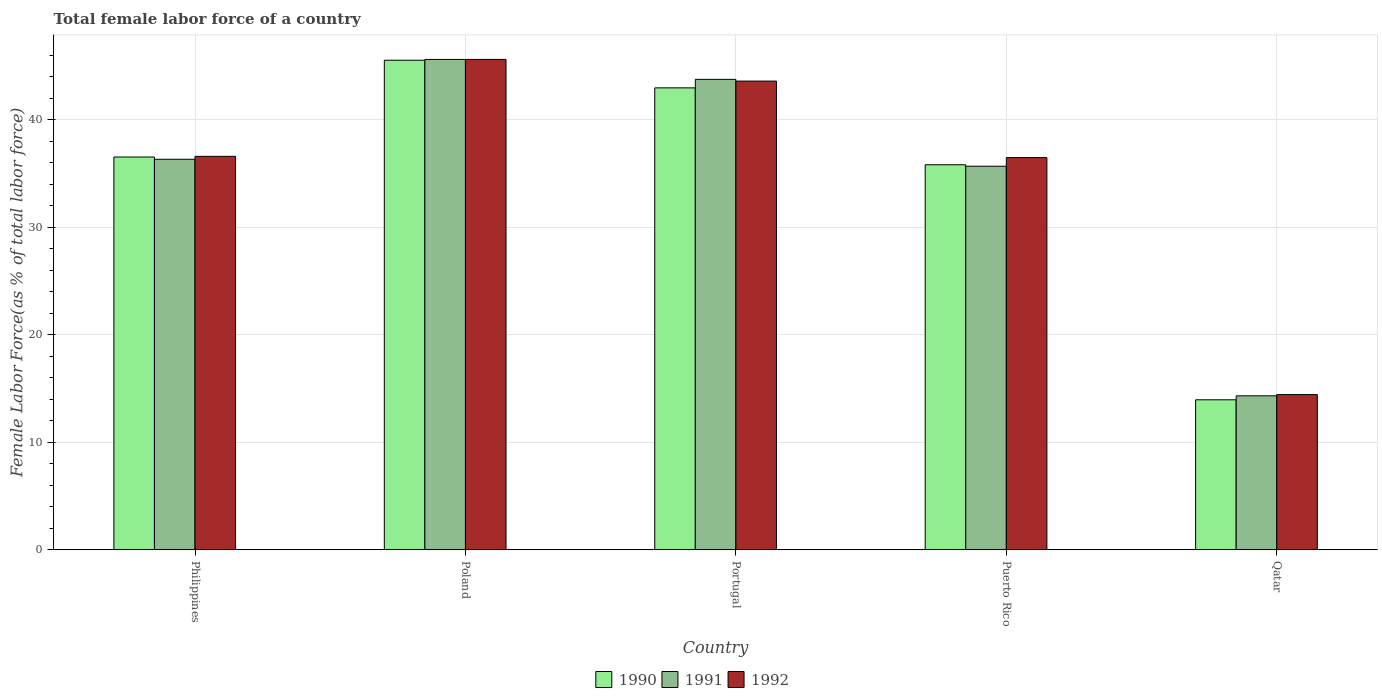How many groups of bars are there?
Give a very brief answer. 5. Are the number of bars per tick equal to the number of legend labels?
Offer a very short reply. Yes. How many bars are there on the 5th tick from the left?
Your answer should be compact. 3. How many bars are there on the 4th tick from the right?
Your answer should be very brief. 3. What is the percentage of female labor force in 1992 in Portugal?
Offer a very short reply. 43.6. Across all countries, what is the maximum percentage of female labor force in 1992?
Make the answer very short. 45.62. Across all countries, what is the minimum percentage of female labor force in 1992?
Provide a succinct answer. 14.44. In which country was the percentage of female labor force in 1992 maximum?
Your answer should be compact. Poland. In which country was the percentage of female labor force in 1990 minimum?
Make the answer very short. Qatar. What is the total percentage of female labor force in 1990 in the graph?
Offer a terse response. 174.84. What is the difference between the percentage of female labor force in 1991 in Philippines and that in Portugal?
Provide a succinct answer. -7.44. What is the difference between the percentage of female labor force in 1992 in Puerto Rico and the percentage of female labor force in 1990 in Portugal?
Your answer should be compact. -6.48. What is the average percentage of female labor force in 1992 per country?
Your answer should be very brief. 35.35. What is the difference between the percentage of female labor force of/in 1992 and percentage of female labor force of/in 1990 in Philippines?
Make the answer very short. 0.06. What is the ratio of the percentage of female labor force in 1992 in Philippines to that in Qatar?
Provide a short and direct response. 2.53. Is the percentage of female labor force in 1990 in Puerto Rico less than that in Qatar?
Your answer should be compact. No. What is the difference between the highest and the second highest percentage of female labor force in 1992?
Your answer should be very brief. 7. What is the difference between the highest and the lowest percentage of female labor force in 1992?
Ensure brevity in your answer.  31.18. What does the 1st bar from the left in Portugal represents?
Your response must be concise. 1990. What does the 3rd bar from the right in Philippines represents?
Offer a terse response. 1990. Is it the case that in every country, the sum of the percentage of female labor force in 1991 and percentage of female labor force in 1992 is greater than the percentage of female labor force in 1990?
Your response must be concise. Yes. Are all the bars in the graph horizontal?
Ensure brevity in your answer.  No. How many countries are there in the graph?
Your response must be concise. 5. How are the legend labels stacked?
Your answer should be compact. Horizontal. What is the title of the graph?
Offer a terse response. Total female labor force of a country. What is the label or title of the Y-axis?
Offer a very short reply. Female Labor Force(as % of total labor force). What is the Female Labor Force(as % of total labor force) of 1990 in Philippines?
Your answer should be compact. 36.54. What is the Female Labor Force(as % of total labor force) in 1991 in Philippines?
Ensure brevity in your answer.  36.33. What is the Female Labor Force(as % of total labor force) in 1992 in Philippines?
Keep it short and to the point. 36.6. What is the Female Labor Force(as % of total labor force) of 1990 in Poland?
Provide a succinct answer. 45.55. What is the Female Labor Force(as % of total labor force) in 1991 in Poland?
Keep it short and to the point. 45.62. What is the Female Labor Force(as % of total labor force) in 1992 in Poland?
Make the answer very short. 45.62. What is the Female Labor Force(as % of total labor force) in 1990 in Portugal?
Your answer should be very brief. 42.97. What is the Female Labor Force(as % of total labor force) of 1991 in Portugal?
Your answer should be compact. 43.77. What is the Female Labor Force(as % of total labor force) of 1992 in Portugal?
Give a very brief answer. 43.6. What is the Female Labor Force(as % of total labor force) in 1990 in Puerto Rico?
Make the answer very short. 35.82. What is the Female Labor Force(as % of total labor force) of 1991 in Puerto Rico?
Keep it short and to the point. 35.69. What is the Female Labor Force(as % of total labor force) of 1992 in Puerto Rico?
Your answer should be compact. 36.49. What is the Female Labor Force(as % of total labor force) of 1990 in Qatar?
Ensure brevity in your answer.  13.96. What is the Female Labor Force(as % of total labor force) of 1991 in Qatar?
Make the answer very short. 14.33. What is the Female Labor Force(as % of total labor force) of 1992 in Qatar?
Give a very brief answer. 14.44. Across all countries, what is the maximum Female Labor Force(as % of total labor force) in 1990?
Your response must be concise. 45.55. Across all countries, what is the maximum Female Labor Force(as % of total labor force) of 1991?
Your answer should be compact. 45.62. Across all countries, what is the maximum Female Labor Force(as % of total labor force) in 1992?
Ensure brevity in your answer.  45.62. Across all countries, what is the minimum Female Labor Force(as % of total labor force) of 1990?
Your answer should be compact. 13.96. Across all countries, what is the minimum Female Labor Force(as % of total labor force) in 1991?
Offer a terse response. 14.33. Across all countries, what is the minimum Female Labor Force(as % of total labor force) in 1992?
Your answer should be compact. 14.44. What is the total Female Labor Force(as % of total labor force) in 1990 in the graph?
Provide a succinct answer. 174.84. What is the total Female Labor Force(as % of total labor force) in 1991 in the graph?
Provide a succinct answer. 175.73. What is the total Female Labor Force(as % of total labor force) in 1992 in the graph?
Provide a succinct answer. 176.76. What is the difference between the Female Labor Force(as % of total labor force) in 1990 in Philippines and that in Poland?
Your response must be concise. -9. What is the difference between the Female Labor Force(as % of total labor force) of 1991 in Philippines and that in Poland?
Your answer should be compact. -9.29. What is the difference between the Female Labor Force(as % of total labor force) of 1992 in Philippines and that in Poland?
Your answer should be compact. -9.02. What is the difference between the Female Labor Force(as % of total labor force) in 1990 in Philippines and that in Portugal?
Ensure brevity in your answer.  -6.43. What is the difference between the Female Labor Force(as % of total labor force) in 1991 in Philippines and that in Portugal?
Make the answer very short. -7.44. What is the difference between the Female Labor Force(as % of total labor force) in 1992 in Philippines and that in Portugal?
Offer a terse response. -7. What is the difference between the Female Labor Force(as % of total labor force) in 1990 in Philippines and that in Puerto Rico?
Give a very brief answer. 0.72. What is the difference between the Female Labor Force(as % of total labor force) of 1991 in Philippines and that in Puerto Rico?
Give a very brief answer. 0.64. What is the difference between the Female Labor Force(as % of total labor force) in 1992 in Philippines and that in Puerto Rico?
Make the answer very short. 0.11. What is the difference between the Female Labor Force(as % of total labor force) of 1990 in Philippines and that in Qatar?
Your answer should be compact. 22.58. What is the difference between the Female Labor Force(as % of total labor force) of 1991 in Philippines and that in Qatar?
Ensure brevity in your answer.  22. What is the difference between the Female Labor Force(as % of total labor force) of 1992 in Philippines and that in Qatar?
Keep it short and to the point. 22.16. What is the difference between the Female Labor Force(as % of total labor force) in 1990 in Poland and that in Portugal?
Offer a terse response. 2.57. What is the difference between the Female Labor Force(as % of total labor force) of 1991 in Poland and that in Portugal?
Your response must be concise. 1.85. What is the difference between the Female Labor Force(as % of total labor force) in 1992 in Poland and that in Portugal?
Your response must be concise. 2.02. What is the difference between the Female Labor Force(as % of total labor force) of 1990 in Poland and that in Puerto Rico?
Provide a short and direct response. 9.72. What is the difference between the Female Labor Force(as % of total labor force) in 1991 in Poland and that in Puerto Rico?
Offer a very short reply. 9.93. What is the difference between the Female Labor Force(as % of total labor force) in 1992 in Poland and that in Puerto Rico?
Ensure brevity in your answer.  9.13. What is the difference between the Female Labor Force(as % of total labor force) of 1990 in Poland and that in Qatar?
Give a very brief answer. 31.59. What is the difference between the Female Labor Force(as % of total labor force) of 1991 in Poland and that in Qatar?
Offer a very short reply. 31.29. What is the difference between the Female Labor Force(as % of total labor force) in 1992 in Poland and that in Qatar?
Your answer should be compact. 31.18. What is the difference between the Female Labor Force(as % of total labor force) in 1990 in Portugal and that in Puerto Rico?
Offer a terse response. 7.15. What is the difference between the Female Labor Force(as % of total labor force) in 1991 in Portugal and that in Puerto Rico?
Your answer should be very brief. 8.08. What is the difference between the Female Labor Force(as % of total labor force) of 1992 in Portugal and that in Puerto Rico?
Your answer should be very brief. 7.12. What is the difference between the Female Labor Force(as % of total labor force) in 1990 in Portugal and that in Qatar?
Offer a terse response. 29.02. What is the difference between the Female Labor Force(as % of total labor force) of 1991 in Portugal and that in Qatar?
Give a very brief answer. 29.44. What is the difference between the Female Labor Force(as % of total labor force) of 1992 in Portugal and that in Qatar?
Your answer should be very brief. 29.16. What is the difference between the Female Labor Force(as % of total labor force) in 1990 in Puerto Rico and that in Qatar?
Your answer should be very brief. 21.86. What is the difference between the Female Labor Force(as % of total labor force) of 1991 in Puerto Rico and that in Qatar?
Your response must be concise. 21.36. What is the difference between the Female Labor Force(as % of total labor force) in 1992 in Puerto Rico and that in Qatar?
Offer a very short reply. 22.05. What is the difference between the Female Labor Force(as % of total labor force) in 1990 in Philippines and the Female Labor Force(as % of total labor force) in 1991 in Poland?
Make the answer very short. -9.08. What is the difference between the Female Labor Force(as % of total labor force) of 1990 in Philippines and the Female Labor Force(as % of total labor force) of 1992 in Poland?
Offer a very short reply. -9.08. What is the difference between the Female Labor Force(as % of total labor force) of 1991 in Philippines and the Female Labor Force(as % of total labor force) of 1992 in Poland?
Your answer should be compact. -9.29. What is the difference between the Female Labor Force(as % of total labor force) in 1990 in Philippines and the Female Labor Force(as % of total labor force) in 1991 in Portugal?
Provide a succinct answer. -7.22. What is the difference between the Female Labor Force(as % of total labor force) of 1990 in Philippines and the Female Labor Force(as % of total labor force) of 1992 in Portugal?
Provide a succinct answer. -7.06. What is the difference between the Female Labor Force(as % of total labor force) of 1991 in Philippines and the Female Labor Force(as % of total labor force) of 1992 in Portugal?
Keep it short and to the point. -7.27. What is the difference between the Female Labor Force(as % of total labor force) in 1990 in Philippines and the Female Labor Force(as % of total labor force) in 1991 in Puerto Rico?
Keep it short and to the point. 0.86. What is the difference between the Female Labor Force(as % of total labor force) of 1990 in Philippines and the Female Labor Force(as % of total labor force) of 1992 in Puerto Rico?
Give a very brief answer. 0.05. What is the difference between the Female Labor Force(as % of total labor force) in 1991 in Philippines and the Female Labor Force(as % of total labor force) in 1992 in Puerto Rico?
Provide a short and direct response. -0.16. What is the difference between the Female Labor Force(as % of total labor force) in 1990 in Philippines and the Female Labor Force(as % of total labor force) in 1991 in Qatar?
Provide a succinct answer. 22.22. What is the difference between the Female Labor Force(as % of total labor force) of 1990 in Philippines and the Female Labor Force(as % of total labor force) of 1992 in Qatar?
Offer a very short reply. 22.1. What is the difference between the Female Labor Force(as % of total labor force) in 1991 in Philippines and the Female Labor Force(as % of total labor force) in 1992 in Qatar?
Keep it short and to the point. 21.89. What is the difference between the Female Labor Force(as % of total labor force) in 1990 in Poland and the Female Labor Force(as % of total labor force) in 1991 in Portugal?
Ensure brevity in your answer.  1.78. What is the difference between the Female Labor Force(as % of total labor force) of 1990 in Poland and the Female Labor Force(as % of total labor force) of 1992 in Portugal?
Provide a short and direct response. 1.94. What is the difference between the Female Labor Force(as % of total labor force) in 1991 in Poland and the Female Labor Force(as % of total labor force) in 1992 in Portugal?
Offer a terse response. 2.02. What is the difference between the Female Labor Force(as % of total labor force) in 1990 in Poland and the Female Labor Force(as % of total labor force) in 1991 in Puerto Rico?
Make the answer very short. 9.86. What is the difference between the Female Labor Force(as % of total labor force) in 1990 in Poland and the Female Labor Force(as % of total labor force) in 1992 in Puerto Rico?
Offer a very short reply. 9.06. What is the difference between the Female Labor Force(as % of total labor force) in 1991 in Poland and the Female Labor Force(as % of total labor force) in 1992 in Puerto Rico?
Ensure brevity in your answer.  9.13. What is the difference between the Female Labor Force(as % of total labor force) in 1990 in Poland and the Female Labor Force(as % of total labor force) in 1991 in Qatar?
Provide a short and direct response. 31.22. What is the difference between the Female Labor Force(as % of total labor force) in 1990 in Poland and the Female Labor Force(as % of total labor force) in 1992 in Qatar?
Provide a short and direct response. 31.1. What is the difference between the Female Labor Force(as % of total labor force) of 1991 in Poland and the Female Labor Force(as % of total labor force) of 1992 in Qatar?
Give a very brief answer. 31.18. What is the difference between the Female Labor Force(as % of total labor force) of 1990 in Portugal and the Female Labor Force(as % of total labor force) of 1991 in Puerto Rico?
Give a very brief answer. 7.29. What is the difference between the Female Labor Force(as % of total labor force) of 1990 in Portugal and the Female Labor Force(as % of total labor force) of 1992 in Puerto Rico?
Offer a terse response. 6.48. What is the difference between the Female Labor Force(as % of total labor force) of 1991 in Portugal and the Female Labor Force(as % of total labor force) of 1992 in Puerto Rico?
Your response must be concise. 7.28. What is the difference between the Female Labor Force(as % of total labor force) in 1990 in Portugal and the Female Labor Force(as % of total labor force) in 1991 in Qatar?
Provide a short and direct response. 28.65. What is the difference between the Female Labor Force(as % of total labor force) of 1990 in Portugal and the Female Labor Force(as % of total labor force) of 1992 in Qatar?
Keep it short and to the point. 28.53. What is the difference between the Female Labor Force(as % of total labor force) of 1991 in Portugal and the Female Labor Force(as % of total labor force) of 1992 in Qatar?
Your answer should be compact. 29.33. What is the difference between the Female Labor Force(as % of total labor force) of 1990 in Puerto Rico and the Female Labor Force(as % of total labor force) of 1991 in Qatar?
Offer a terse response. 21.49. What is the difference between the Female Labor Force(as % of total labor force) in 1990 in Puerto Rico and the Female Labor Force(as % of total labor force) in 1992 in Qatar?
Your answer should be very brief. 21.38. What is the difference between the Female Labor Force(as % of total labor force) of 1991 in Puerto Rico and the Female Labor Force(as % of total labor force) of 1992 in Qatar?
Ensure brevity in your answer.  21.24. What is the average Female Labor Force(as % of total labor force) in 1990 per country?
Give a very brief answer. 34.97. What is the average Female Labor Force(as % of total labor force) of 1991 per country?
Your answer should be compact. 35.15. What is the average Female Labor Force(as % of total labor force) in 1992 per country?
Your answer should be compact. 35.35. What is the difference between the Female Labor Force(as % of total labor force) in 1990 and Female Labor Force(as % of total labor force) in 1991 in Philippines?
Your answer should be very brief. 0.21. What is the difference between the Female Labor Force(as % of total labor force) of 1990 and Female Labor Force(as % of total labor force) of 1992 in Philippines?
Ensure brevity in your answer.  -0.06. What is the difference between the Female Labor Force(as % of total labor force) of 1991 and Female Labor Force(as % of total labor force) of 1992 in Philippines?
Provide a short and direct response. -0.27. What is the difference between the Female Labor Force(as % of total labor force) of 1990 and Female Labor Force(as % of total labor force) of 1991 in Poland?
Provide a short and direct response. -0.07. What is the difference between the Female Labor Force(as % of total labor force) in 1990 and Female Labor Force(as % of total labor force) in 1992 in Poland?
Provide a short and direct response. -0.08. What is the difference between the Female Labor Force(as % of total labor force) in 1991 and Female Labor Force(as % of total labor force) in 1992 in Poland?
Your answer should be compact. -0. What is the difference between the Female Labor Force(as % of total labor force) of 1990 and Female Labor Force(as % of total labor force) of 1991 in Portugal?
Your response must be concise. -0.79. What is the difference between the Female Labor Force(as % of total labor force) of 1990 and Female Labor Force(as % of total labor force) of 1992 in Portugal?
Offer a terse response. -0.63. What is the difference between the Female Labor Force(as % of total labor force) in 1991 and Female Labor Force(as % of total labor force) in 1992 in Portugal?
Provide a succinct answer. 0.16. What is the difference between the Female Labor Force(as % of total labor force) of 1990 and Female Labor Force(as % of total labor force) of 1991 in Puerto Rico?
Offer a terse response. 0.14. What is the difference between the Female Labor Force(as % of total labor force) of 1990 and Female Labor Force(as % of total labor force) of 1992 in Puerto Rico?
Offer a very short reply. -0.67. What is the difference between the Female Labor Force(as % of total labor force) of 1991 and Female Labor Force(as % of total labor force) of 1992 in Puerto Rico?
Offer a terse response. -0.8. What is the difference between the Female Labor Force(as % of total labor force) of 1990 and Female Labor Force(as % of total labor force) of 1991 in Qatar?
Make the answer very short. -0.37. What is the difference between the Female Labor Force(as % of total labor force) of 1990 and Female Labor Force(as % of total labor force) of 1992 in Qatar?
Provide a short and direct response. -0.48. What is the difference between the Female Labor Force(as % of total labor force) of 1991 and Female Labor Force(as % of total labor force) of 1992 in Qatar?
Ensure brevity in your answer.  -0.11. What is the ratio of the Female Labor Force(as % of total labor force) in 1990 in Philippines to that in Poland?
Your answer should be compact. 0.8. What is the ratio of the Female Labor Force(as % of total labor force) of 1991 in Philippines to that in Poland?
Keep it short and to the point. 0.8. What is the ratio of the Female Labor Force(as % of total labor force) of 1992 in Philippines to that in Poland?
Your answer should be compact. 0.8. What is the ratio of the Female Labor Force(as % of total labor force) in 1990 in Philippines to that in Portugal?
Make the answer very short. 0.85. What is the ratio of the Female Labor Force(as % of total labor force) of 1991 in Philippines to that in Portugal?
Keep it short and to the point. 0.83. What is the ratio of the Female Labor Force(as % of total labor force) in 1992 in Philippines to that in Portugal?
Your response must be concise. 0.84. What is the ratio of the Female Labor Force(as % of total labor force) in 1990 in Philippines to that in Puerto Rico?
Your response must be concise. 1.02. What is the ratio of the Female Labor Force(as % of total labor force) of 1991 in Philippines to that in Puerto Rico?
Offer a very short reply. 1.02. What is the ratio of the Female Labor Force(as % of total labor force) in 1992 in Philippines to that in Puerto Rico?
Your response must be concise. 1. What is the ratio of the Female Labor Force(as % of total labor force) in 1990 in Philippines to that in Qatar?
Offer a very short reply. 2.62. What is the ratio of the Female Labor Force(as % of total labor force) of 1991 in Philippines to that in Qatar?
Your answer should be compact. 2.54. What is the ratio of the Female Labor Force(as % of total labor force) in 1992 in Philippines to that in Qatar?
Offer a very short reply. 2.53. What is the ratio of the Female Labor Force(as % of total labor force) of 1990 in Poland to that in Portugal?
Ensure brevity in your answer.  1.06. What is the ratio of the Female Labor Force(as % of total labor force) of 1991 in Poland to that in Portugal?
Your answer should be very brief. 1.04. What is the ratio of the Female Labor Force(as % of total labor force) in 1992 in Poland to that in Portugal?
Ensure brevity in your answer.  1.05. What is the ratio of the Female Labor Force(as % of total labor force) in 1990 in Poland to that in Puerto Rico?
Provide a succinct answer. 1.27. What is the ratio of the Female Labor Force(as % of total labor force) in 1991 in Poland to that in Puerto Rico?
Offer a very short reply. 1.28. What is the ratio of the Female Labor Force(as % of total labor force) in 1992 in Poland to that in Puerto Rico?
Make the answer very short. 1.25. What is the ratio of the Female Labor Force(as % of total labor force) in 1990 in Poland to that in Qatar?
Offer a terse response. 3.26. What is the ratio of the Female Labor Force(as % of total labor force) of 1991 in Poland to that in Qatar?
Ensure brevity in your answer.  3.18. What is the ratio of the Female Labor Force(as % of total labor force) of 1992 in Poland to that in Qatar?
Your response must be concise. 3.16. What is the ratio of the Female Labor Force(as % of total labor force) of 1990 in Portugal to that in Puerto Rico?
Offer a terse response. 1.2. What is the ratio of the Female Labor Force(as % of total labor force) in 1991 in Portugal to that in Puerto Rico?
Keep it short and to the point. 1.23. What is the ratio of the Female Labor Force(as % of total labor force) in 1992 in Portugal to that in Puerto Rico?
Your answer should be very brief. 1.2. What is the ratio of the Female Labor Force(as % of total labor force) of 1990 in Portugal to that in Qatar?
Your answer should be very brief. 3.08. What is the ratio of the Female Labor Force(as % of total labor force) in 1991 in Portugal to that in Qatar?
Offer a very short reply. 3.05. What is the ratio of the Female Labor Force(as % of total labor force) of 1992 in Portugal to that in Qatar?
Your answer should be compact. 3.02. What is the ratio of the Female Labor Force(as % of total labor force) in 1990 in Puerto Rico to that in Qatar?
Your response must be concise. 2.57. What is the ratio of the Female Labor Force(as % of total labor force) in 1991 in Puerto Rico to that in Qatar?
Your answer should be very brief. 2.49. What is the ratio of the Female Labor Force(as % of total labor force) in 1992 in Puerto Rico to that in Qatar?
Offer a very short reply. 2.53. What is the difference between the highest and the second highest Female Labor Force(as % of total labor force) in 1990?
Make the answer very short. 2.57. What is the difference between the highest and the second highest Female Labor Force(as % of total labor force) of 1991?
Your response must be concise. 1.85. What is the difference between the highest and the second highest Female Labor Force(as % of total labor force) in 1992?
Make the answer very short. 2.02. What is the difference between the highest and the lowest Female Labor Force(as % of total labor force) of 1990?
Offer a terse response. 31.59. What is the difference between the highest and the lowest Female Labor Force(as % of total labor force) in 1991?
Make the answer very short. 31.29. What is the difference between the highest and the lowest Female Labor Force(as % of total labor force) in 1992?
Keep it short and to the point. 31.18. 